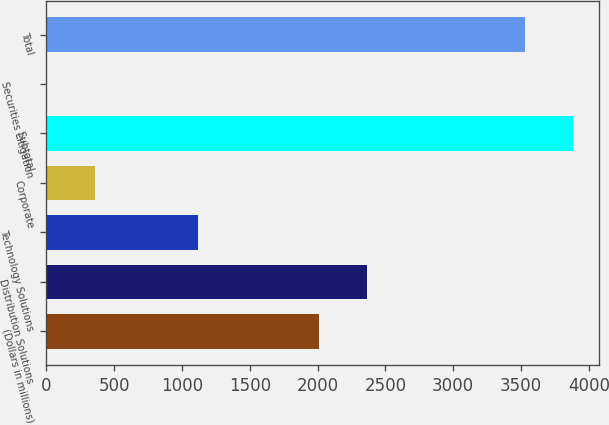Convert chart. <chart><loc_0><loc_0><loc_500><loc_500><bar_chart><fcel>(Dollars in millions)<fcel>Distribution Solutions<fcel>Technology Solutions<fcel>Corporate<fcel>Subtotal<fcel>Securities Litigation<fcel>Total<nl><fcel>2008<fcel>2361.1<fcel>1115<fcel>358.1<fcel>3884.1<fcel>5<fcel>3531<nl></chart> 